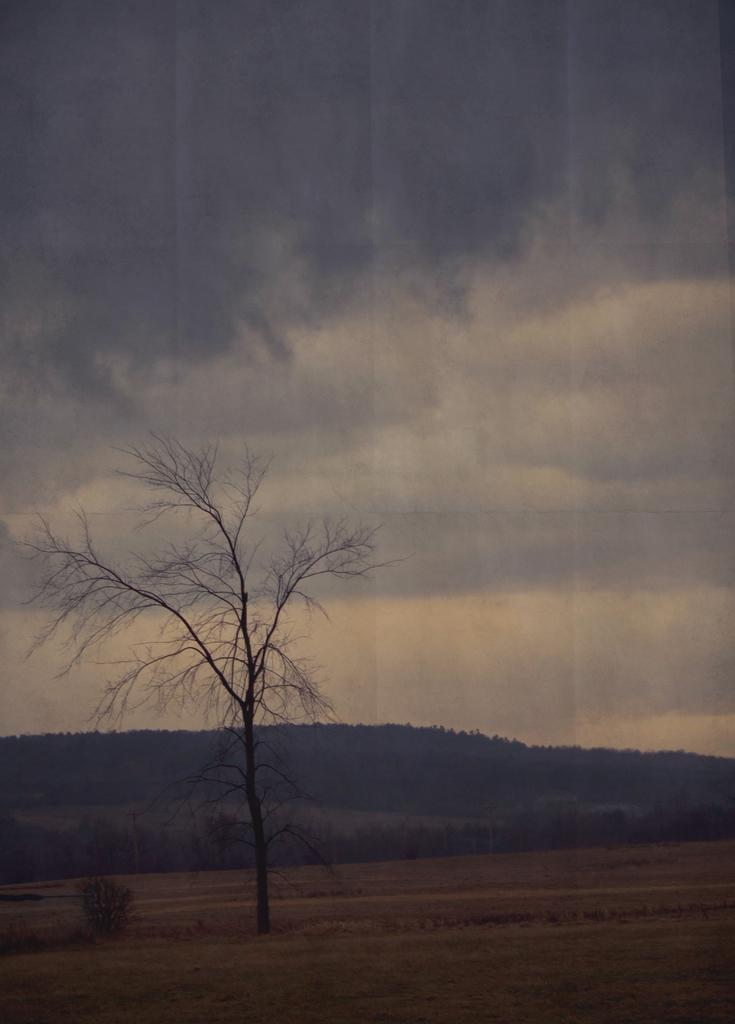What type of vegetation can be seen in the image? There is a tree, grassland, and plants in the image. What is the terrain like in the image? There are hills in the image. What can be seen in the background of the image? The sky is visible in the background of the image, and there are clouds in the sky. What type of substance is being used to create a quiet atmosphere in the image? There is no mention of a substance being used to create a quiet atmosphere in the image. The image primarily features natural elements such as a tree, grassland, plants, hills, sky, and clouds. 